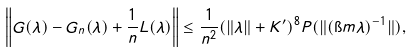Convert formula to latex. <formula><loc_0><loc_0><loc_500><loc_500>\left \| G ( \lambda ) - G _ { n } ( \lambda ) + \frac { 1 } { n } L ( \lambda ) \right \| \leq \frac { 1 } { n ^ { 2 } } ( \| \lambda \| + K ^ { \prime } ) ^ { 8 } P ( \| ( \i m \lambda ) ^ { - 1 } \| ) ,</formula> 